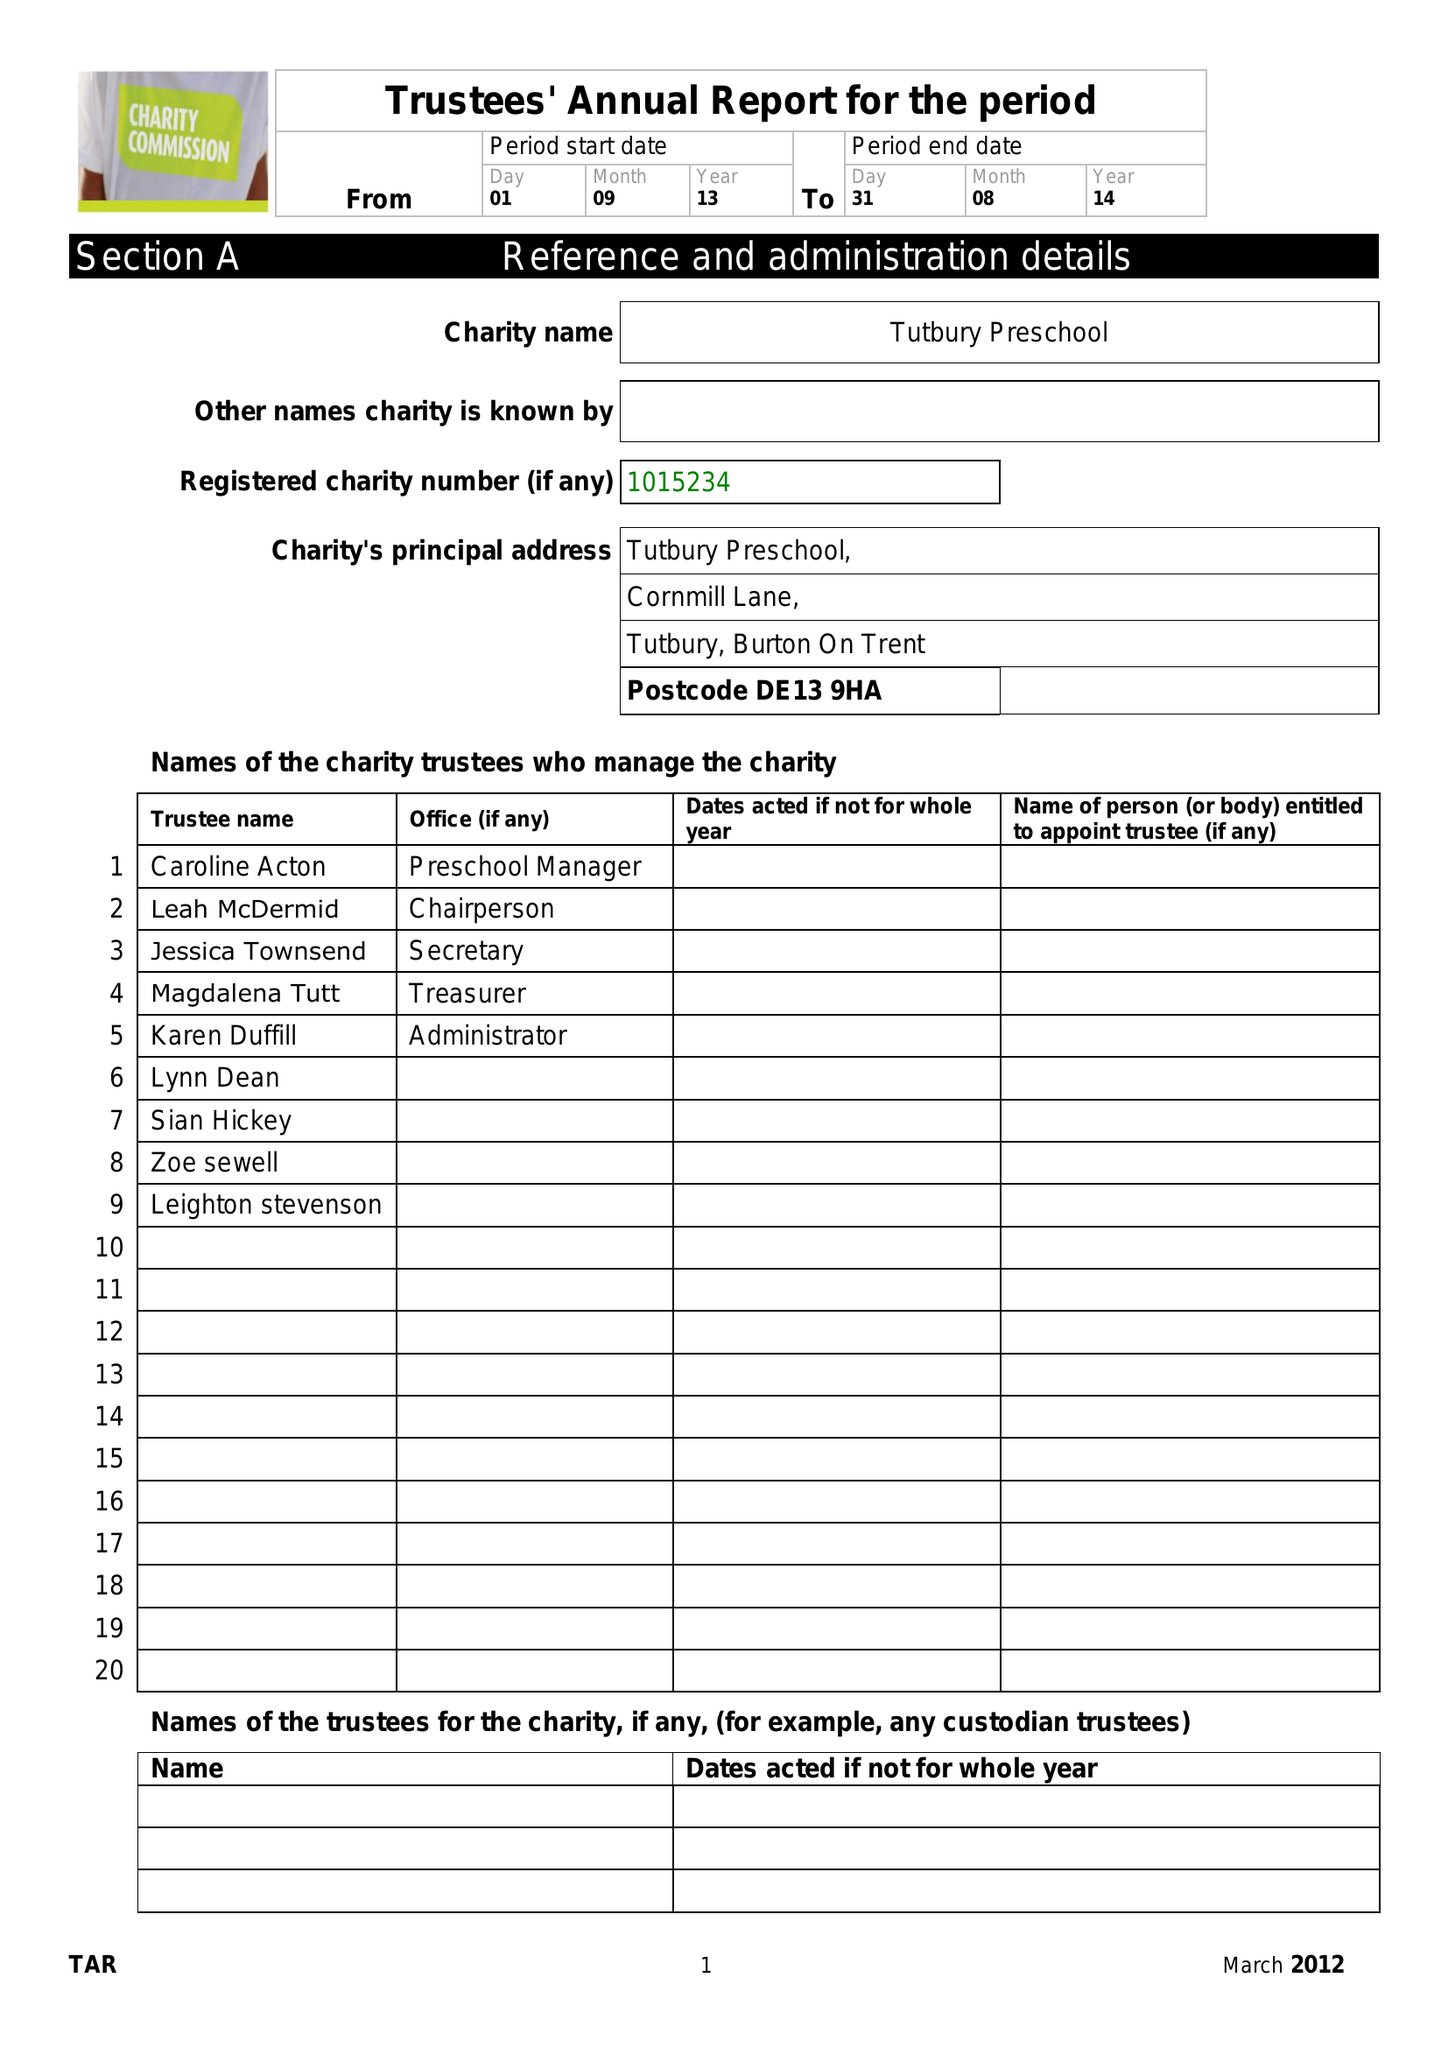What is the value for the report_date?
Answer the question using a single word or phrase. 2014-08-31 